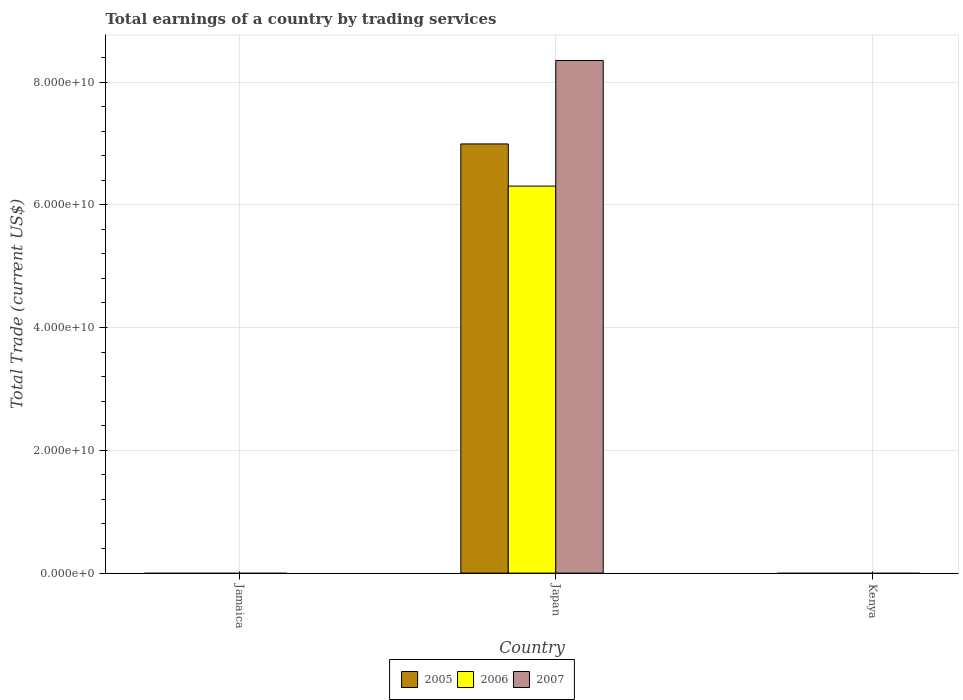Are the number of bars per tick equal to the number of legend labels?
Ensure brevity in your answer.  No. What is the label of the 2nd group of bars from the left?
Offer a very short reply. Japan. What is the total earnings in 2006 in Japan?
Provide a succinct answer. 6.30e+1. Across all countries, what is the maximum total earnings in 2005?
Your answer should be very brief. 6.99e+1. What is the total total earnings in 2005 in the graph?
Provide a succinct answer. 6.99e+1. What is the difference between the total earnings in 2006 in Kenya and the total earnings in 2005 in Japan?
Your response must be concise. -6.99e+1. What is the average total earnings in 2007 per country?
Ensure brevity in your answer.  2.78e+1. What is the difference between the total earnings of/in 2006 and total earnings of/in 2005 in Japan?
Give a very brief answer. -6.87e+09. What is the difference between the highest and the lowest total earnings in 2007?
Keep it short and to the point. 8.35e+1. Is it the case that in every country, the sum of the total earnings in 2005 and total earnings in 2007 is greater than the total earnings in 2006?
Keep it short and to the point. No. Are all the bars in the graph horizontal?
Your answer should be compact. No. How many countries are there in the graph?
Provide a short and direct response. 3. Are the values on the major ticks of Y-axis written in scientific E-notation?
Ensure brevity in your answer.  Yes. How are the legend labels stacked?
Give a very brief answer. Horizontal. What is the title of the graph?
Make the answer very short. Total earnings of a country by trading services. What is the label or title of the Y-axis?
Your response must be concise. Total Trade (current US$). What is the Total Trade (current US$) in 2007 in Jamaica?
Your response must be concise. 0. What is the Total Trade (current US$) in 2005 in Japan?
Make the answer very short. 6.99e+1. What is the Total Trade (current US$) of 2006 in Japan?
Offer a terse response. 6.30e+1. What is the Total Trade (current US$) of 2007 in Japan?
Give a very brief answer. 8.35e+1. What is the Total Trade (current US$) of 2005 in Kenya?
Provide a succinct answer. 0. What is the Total Trade (current US$) in 2006 in Kenya?
Provide a succinct answer. 0. What is the Total Trade (current US$) of 2007 in Kenya?
Make the answer very short. 0. Across all countries, what is the maximum Total Trade (current US$) of 2005?
Your answer should be compact. 6.99e+1. Across all countries, what is the maximum Total Trade (current US$) of 2006?
Give a very brief answer. 6.30e+1. Across all countries, what is the maximum Total Trade (current US$) of 2007?
Provide a succinct answer. 8.35e+1. Across all countries, what is the minimum Total Trade (current US$) in 2005?
Keep it short and to the point. 0. Across all countries, what is the minimum Total Trade (current US$) in 2006?
Provide a short and direct response. 0. Across all countries, what is the minimum Total Trade (current US$) of 2007?
Offer a very short reply. 0. What is the total Total Trade (current US$) of 2005 in the graph?
Offer a very short reply. 6.99e+1. What is the total Total Trade (current US$) in 2006 in the graph?
Give a very brief answer. 6.30e+1. What is the total Total Trade (current US$) of 2007 in the graph?
Your answer should be compact. 8.35e+1. What is the average Total Trade (current US$) of 2005 per country?
Make the answer very short. 2.33e+1. What is the average Total Trade (current US$) in 2006 per country?
Your answer should be compact. 2.10e+1. What is the average Total Trade (current US$) in 2007 per country?
Give a very brief answer. 2.78e+1. What is the difference between the Total Trade (current US$) in 2005 and Total Trade (current US$) in 2006 in Japan?
Provide a short and direct response. 6.87e+09. What is the difference between the Total Trade (current US$) of 2005 and Total Trade (current US$) of 2007 in Japan?
Your answer should be compact. -1.36e+1. What is the difference between the Total Trade (current US$) in 2006 and Total Trade (current US$) in 2007 in Japan?
Offer a very short reply. -2.05e+1. What is the difference between the highest and the lowest Total Trade (current US$) in 2005?
Your answer should be compact. 6.99e+1. What is the difference between the highest and the lowest Total Trade (current US$) of 2006?
Your response must be concise. 6.30e+1. What is the difference between the highest and the lowest Total Trade (current US$) in 2007?
Give a very brief answer. 8.35e+1. 